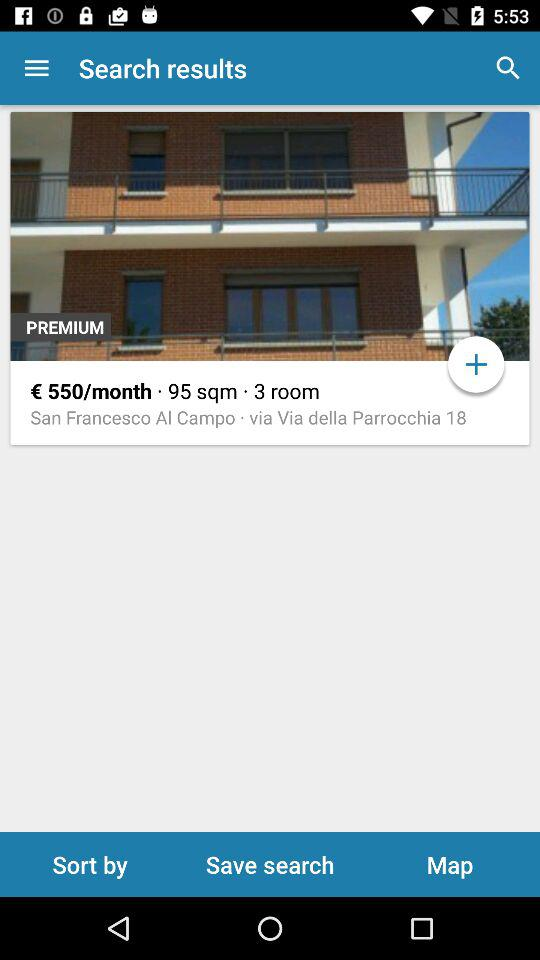How many rooms does this apartment have?
Answer the question using a single word or phrase. 3 